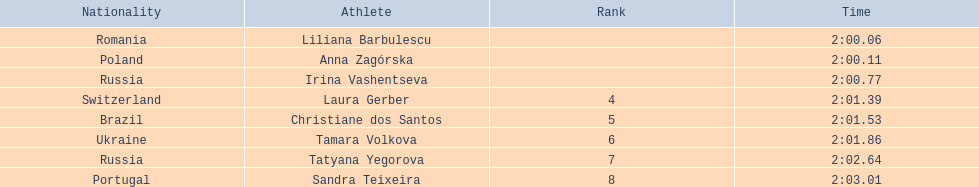Anna zagorska recieved 2nd place, what was her time? 2:00.11. 